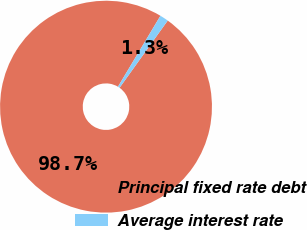<chart> <loc_0><loc_0><loc_500><loc_500><pie_chart><fcel>Principal fixed rate debt<fcel>Average interest rate<nl><fcel>98.69%<fcel>1.31%<nl></chart> 